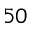Convert formula to latex. <formula><loc_0><loc_0><loc_500><loc_500>^ { 5 0 }</formula> 